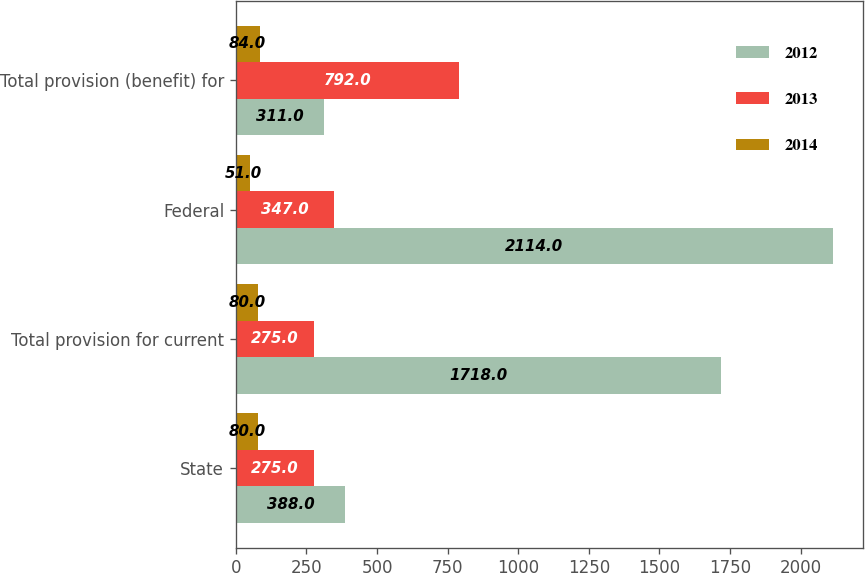Convert chart. <chart><loc_0><loc_0><loc_500><loc_500><stacked_bar_chart><ecel><fcel>State<fcel>Total provision for current<fcel>Federal<fcel>Total provision (benefit) for<nl><fcel>2012<fcel>388<fcel>1718<fcel>2114<fcel>311<nl><fcel>2013<fcel>275<fcel>275<fcel>347<fcel>792<nl><fcel>2014<fcel>80<fcel>80<fcel>51<fcel>84<nl></chart> 